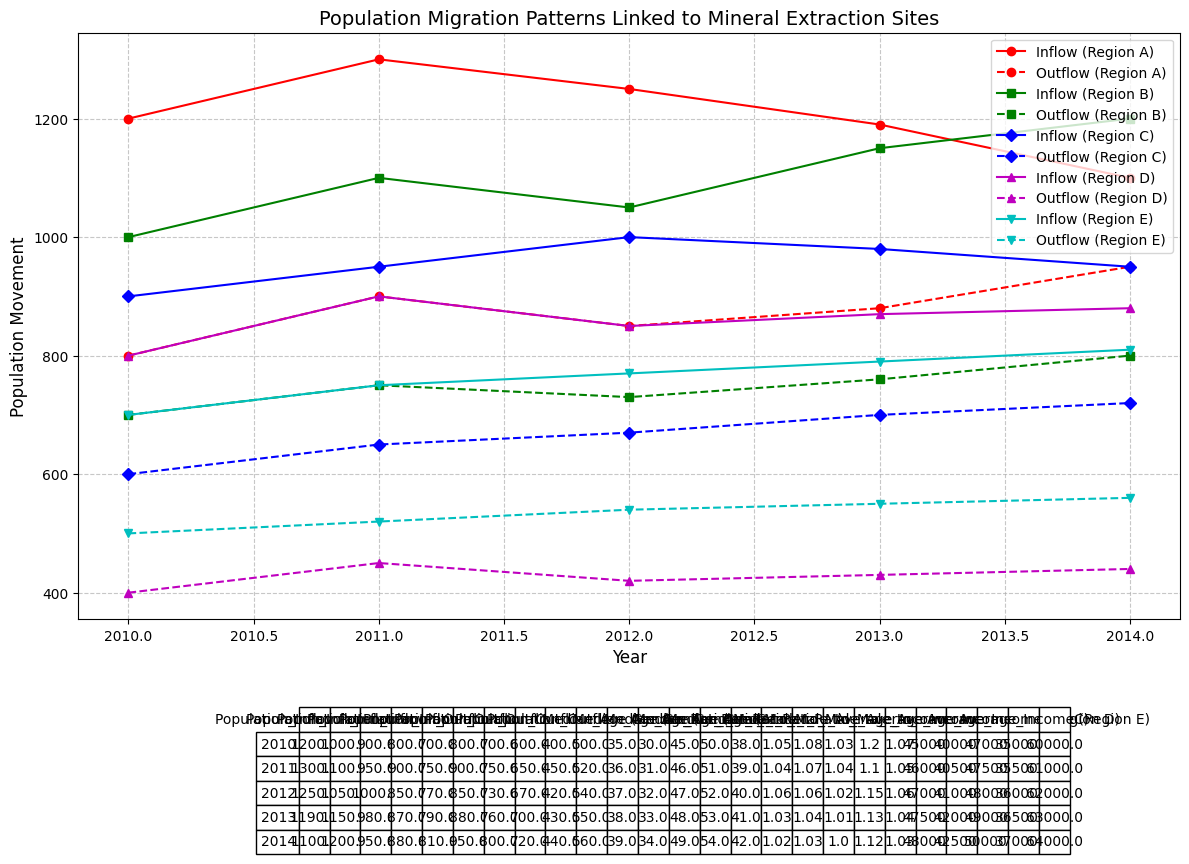what's the overall trend in population inflow for Region A over the years? The visual plot shows that the population inflow for Region A decreased from 1200 in 2010 to 1100 in 2014. Each year, the inflow steadily decreases reflecting a downward trend.
Answer: It declined Which Region had the highest average income in 2014? By examining the data values for the year 2014 across all regions, Region E with Uranium extraction has the highest average income of 64000.
Answer: Region E What was the population outflow for Region B in 2013, and how does it compare to Region A's population outflow in the same year? The population outflow for Region B in 2013 is 760, while for Region A it is 880. Comparing these two, Region A had a higher population outflow by a difference of 120 people.
Answer: Region A had a higher outflow What is the gender ratio trend for Region D from 2010 to 2014? From the table, the gender ratio (Male to Female) for Region D decreases from 1.2 in 2010 to 1.12 in 2014. This shows a downward trend in the gender ratio over the years.
Answer: Decreasing trend How does the median age in Region E, where Uranium is extracted, change from 2010 to 2014? The median age in Region E increases every year, starting from 38 in 2010 and reaching 42 in 2014. This is a consistent upward trend in median age for Region E.
Answer: Increasing trend Which region shows the most significant difference between population inflow and outflow in 2010? In 2010, Region A has a difference of 400 (Inflow 1200 - Outflow 800), Region B has 300 (Inflow 1000 - Outflow 700), Region C has 300 (Inflow 900 - Outflow 600), Region D has 400 (Inflow 800 - Outflow 400), and Region E has 200 (Inflow 700 - Outflow 500). Thus, both Region A and Region D show the most significant difference of 400.
Answer: Regions A and D What's the average income trend for Region C from 2010 to 2014? Analyzing the data for Region C from 2010 to 2014, the average income increases each year: from 47000 in 2010 to 50000 in 2014. This indicates an upward trend in the average income over these years.
Answer: Increasing trend If you sum the population inflow and outflow for Region D in 2012, what is the result? The population inflow for Region D in 2012 is 850, and the outflow is 420. Adding these two numbers together 850 + 420 results in 1270.
Answer: 1270 